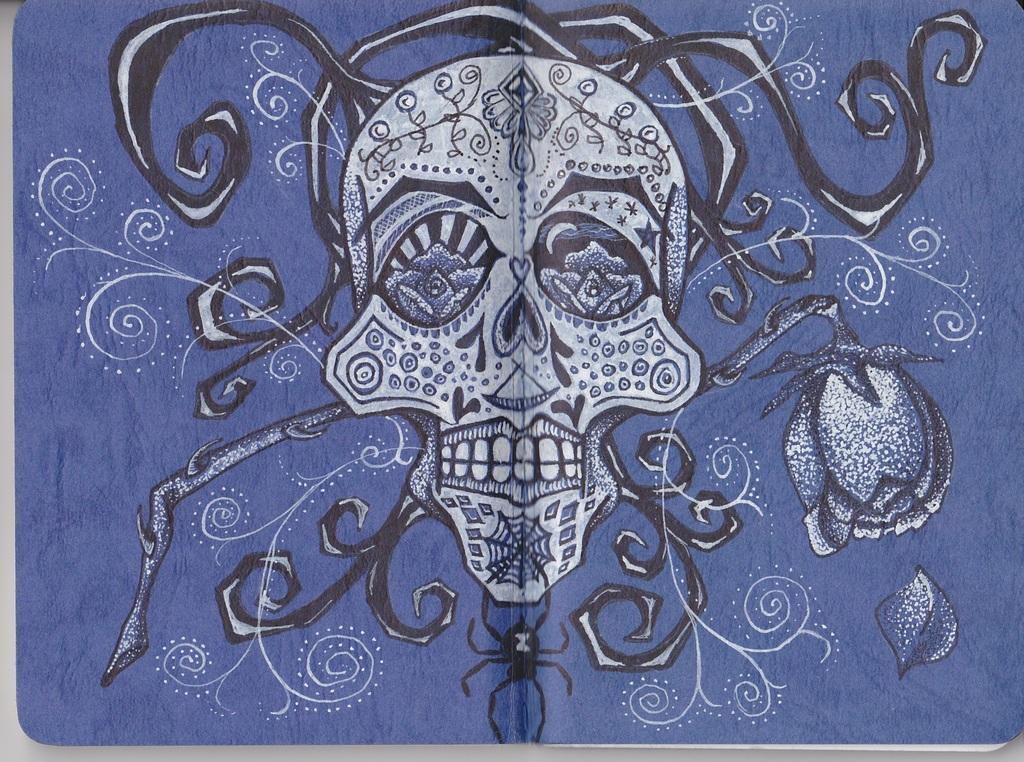Please provide a concise description of this image. In the picture we can see the painting of a skull on the cloth with designs. 